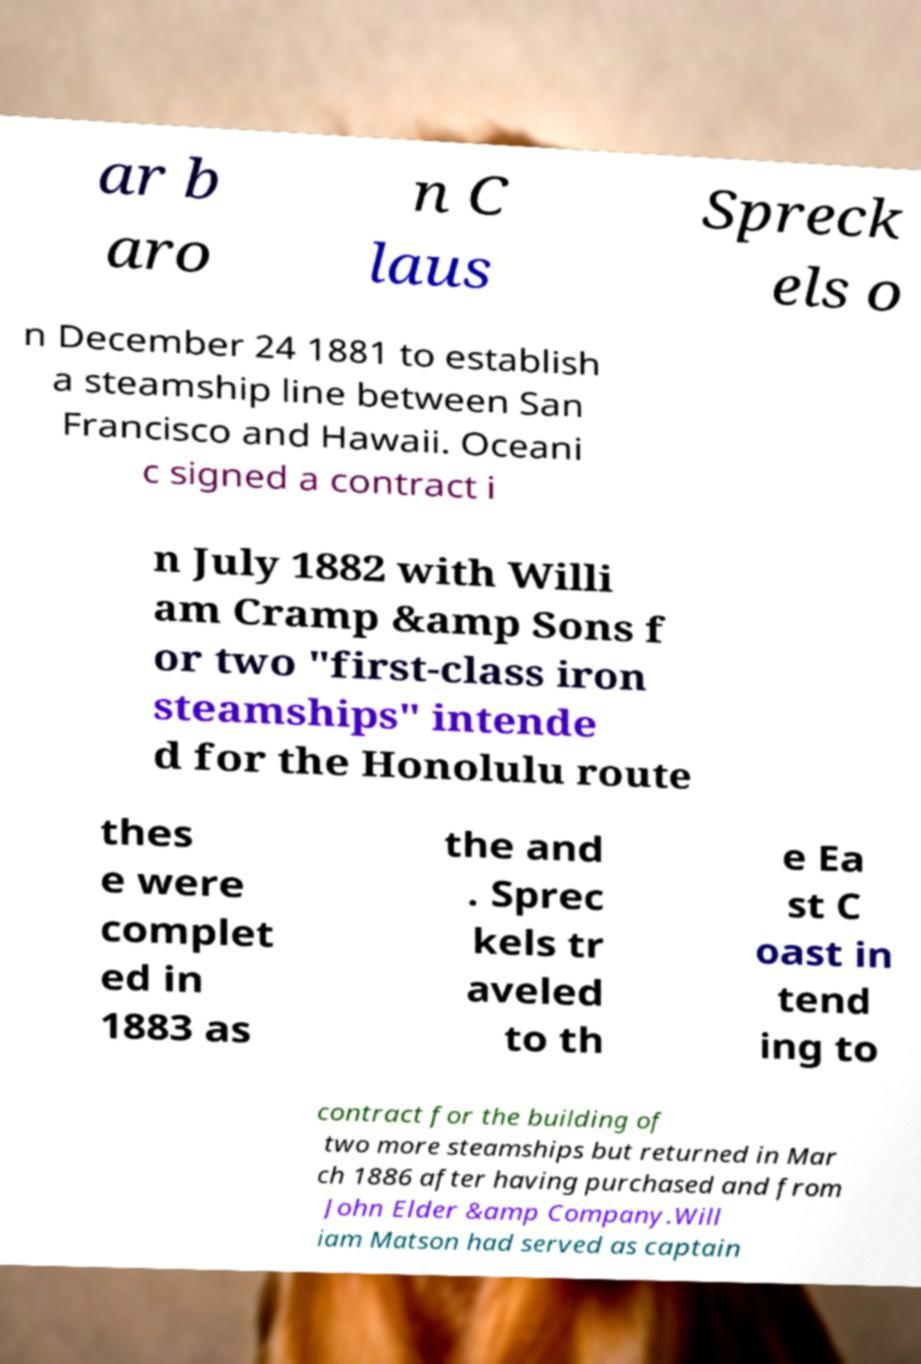Could you extract and type out the text from this image? ar b aro n C laus Spreck els o n December 24 1881 to establish a steamship line between San Francisco and Hawaii. Oceani c signed a contract i n July 1882 with Willi am Cramp &amp Sons f or two "first-class iron steamships" intende d for the Honolulu route thes e were complet ed in 1883 as the and . Sprec kels tr aveled to th e Ea st C oast in tend ing to contract for the building of two more steamships but returned in Mar ch 1886 after having purchased and from John Elder &amp Company.Will iam Matson had served as captain 